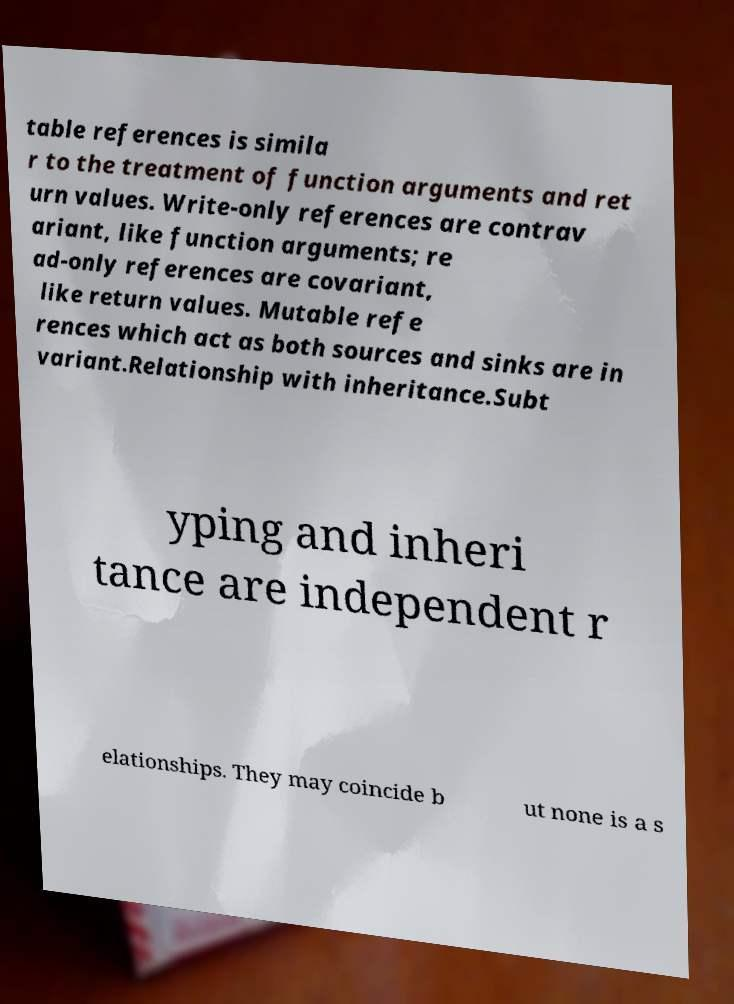Could you assist in decoding the text presented in this image and type it out clearly? table references is simila r to the treatment of function arguments and ret urn values. Write-only references are contrav ariant, like function arguments; re ad-only references are covariant, like return values. Mutable refe rences which act as both sources and sinks are in variant.Relationship with inheritance.Subt yping and inheri tance are independent r elationships. They may coincide b ut none is a s 